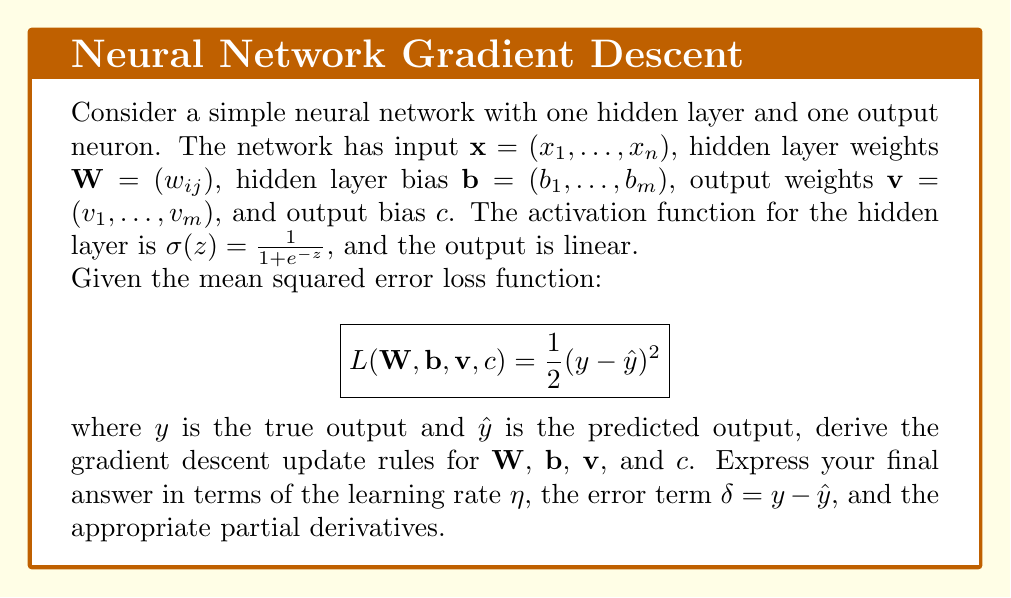Provide a solution to this math problem. To derive the gradient descent update rules, we need to calculate the partial derivatives of the loss function with respect to each parameter and use them to update the parameters in the direction that minimizes the loss.

Step 1: Forward pass
Let's define the forward pass of the neural network:

1. Hidden layer: $h_j = \sigma(\sum_{i=1}^n w_{ij}x_i + b_j)$
2. Output: $\hat{y} = \sum_{j=1}^m v_j h_j + c$

Step 2: Partial derivatives
We'll use the chain rule to calculate the partial derivatives:

1. For output bias $c$:
   $$\frac{\partial L}{\partial c} = \frac{\partial L}{\partial \hat{y}} \cdot \frac{\partial \hat{y}}{\partial c} = -(y - \hat{y}) \cdot 1 = -\delta$$

2. For output weights $v_j$:
   $$\frac{\partial L}{\partial v_j} = \frac{\partial L}{\partial \hat{y}} \cdot \frac{\partial \hat{y}}{\partial v_j} = -(y - \hat{y}) \cdot h_j = -\delta h_j$$

3. For hidden layer bias $b_j$:
   $$\frac{\partial L}{\partial b_j} = \frac{\partial L}{\partial \hat{y}} \cdot \frac{\partial \hat{y}}{\partial h_j} \cdot \frac{\partial h_j}{\partial b_j} = -\delta \cdot v_j \cdot h_j(1-h_j)$$

4. For hidden layer weights $w_{ij}$:
   $$\frac{\partial L}{\partial w_{ij}} = \frac{\partial L}{\partial \hat{y}} \cdot \frac{\partial \hat{y}}{\partial h_j} \cdot \frac{\partial h_j}{\partial w_{ij}} = -\delta \cdot v_j \cdot h_j(1-h_j) \cdot x_i$$

Step 3: Gradient descent update rules
Using the partial derivatives, we can now write the update rules:

1. $c \leftarrow c - \eta \frac{\partial L}{\partial c} = c + \eta \delta$
2. $v_j \leftarrow v_j - \eta \frac{\partial L}{\partial v_j} = v_j + \eta \delta h_j$
3. $b_j \leftarrow b_j - \eta \frac{\partial L}{\partial b_j} = b_j + \eta \delta v_j h_j(1-h_j)$
4. $w_{ij} \leftarrow w_{ij} - \eta \frac{\partial L}{\partial w_{ij}} = w_{ij} + \eta \delta v_j h_j(1-h_j) x_i$

These update rules form the gradient descent algorithm for optimizing the neural network weights.
Answer: $c \leftarrow c + \eta \delta$
$v_j \leftarrow v_j + \eta \delta h_j$
$b_j \leftarrow b_j + \eta \delta v_j h_j(1-h_j)$
$w_{ij} \leftarrow w_{ij} + \eta \delta v_j h_j(1-h_j) x_i$ 